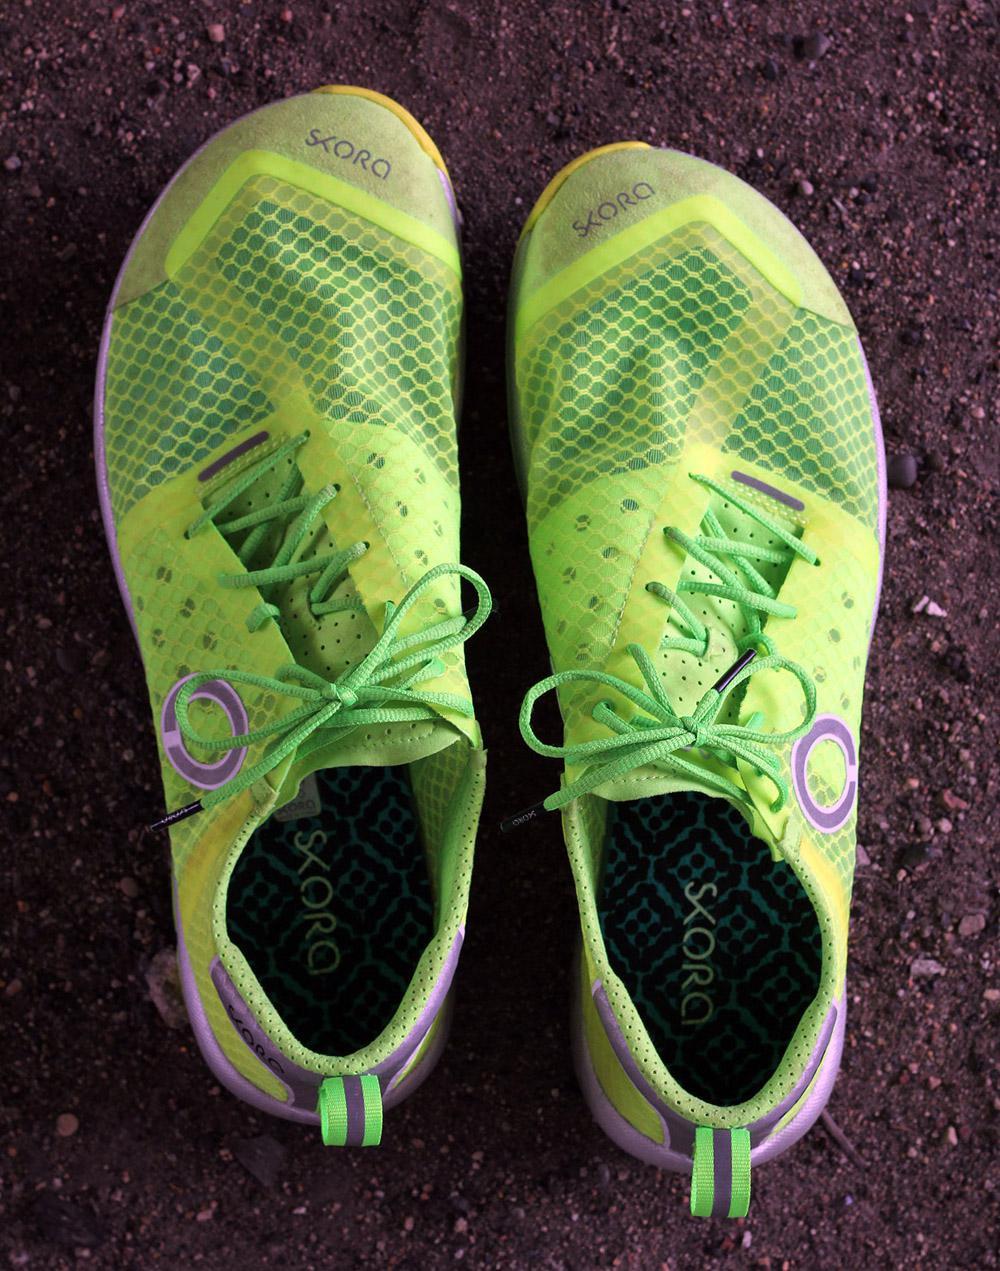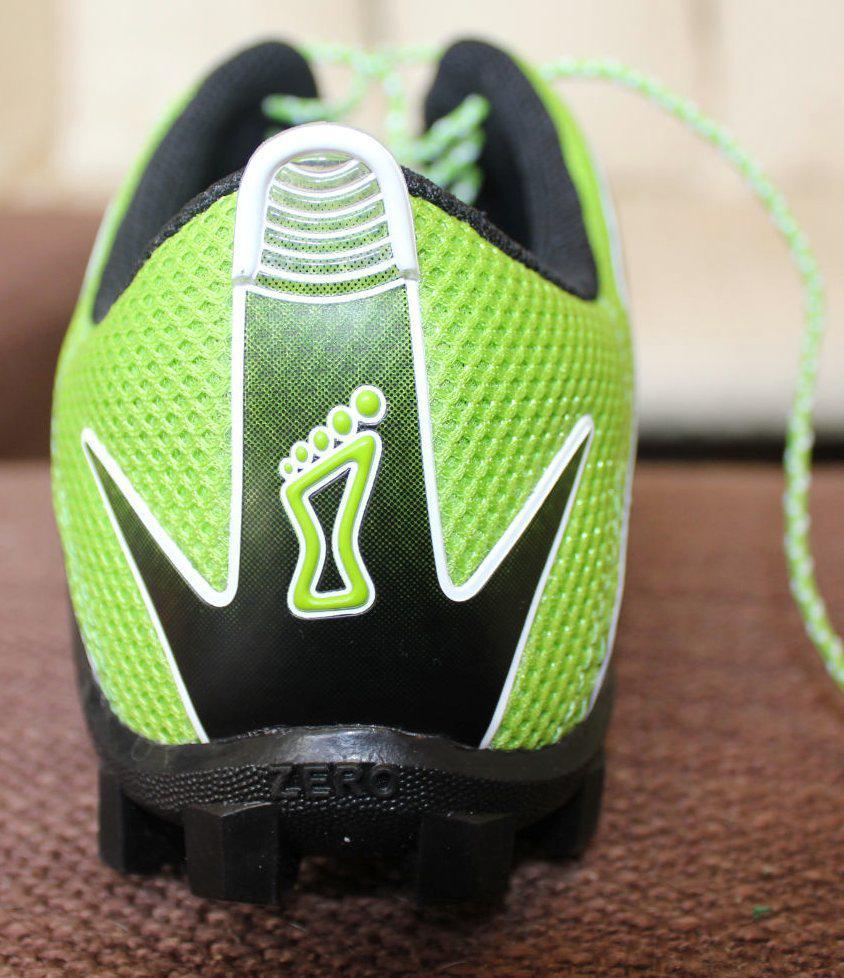The first image is the image on the left, the second image is the image on the right. Examine the images to the left and right. Is the description "At least one image shows a pair of running shoes that are being worn on a person's feet" accurate? Answer yes or no. No. The first image is the image on the left, the second image is the image on the right. Analyze the images presented: Is the assertion "One image is a top-view of human feet wearing matching sneakers with white laces." valid? Answer yes or no. No. 